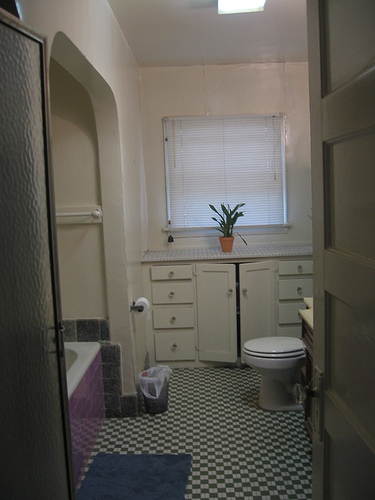<image>Where is the towel? There is no towel in the image. It could possibly be in the bathroom or on the ground. Where is the towel? I don't know where the towel is located. There is no towel in the image. 